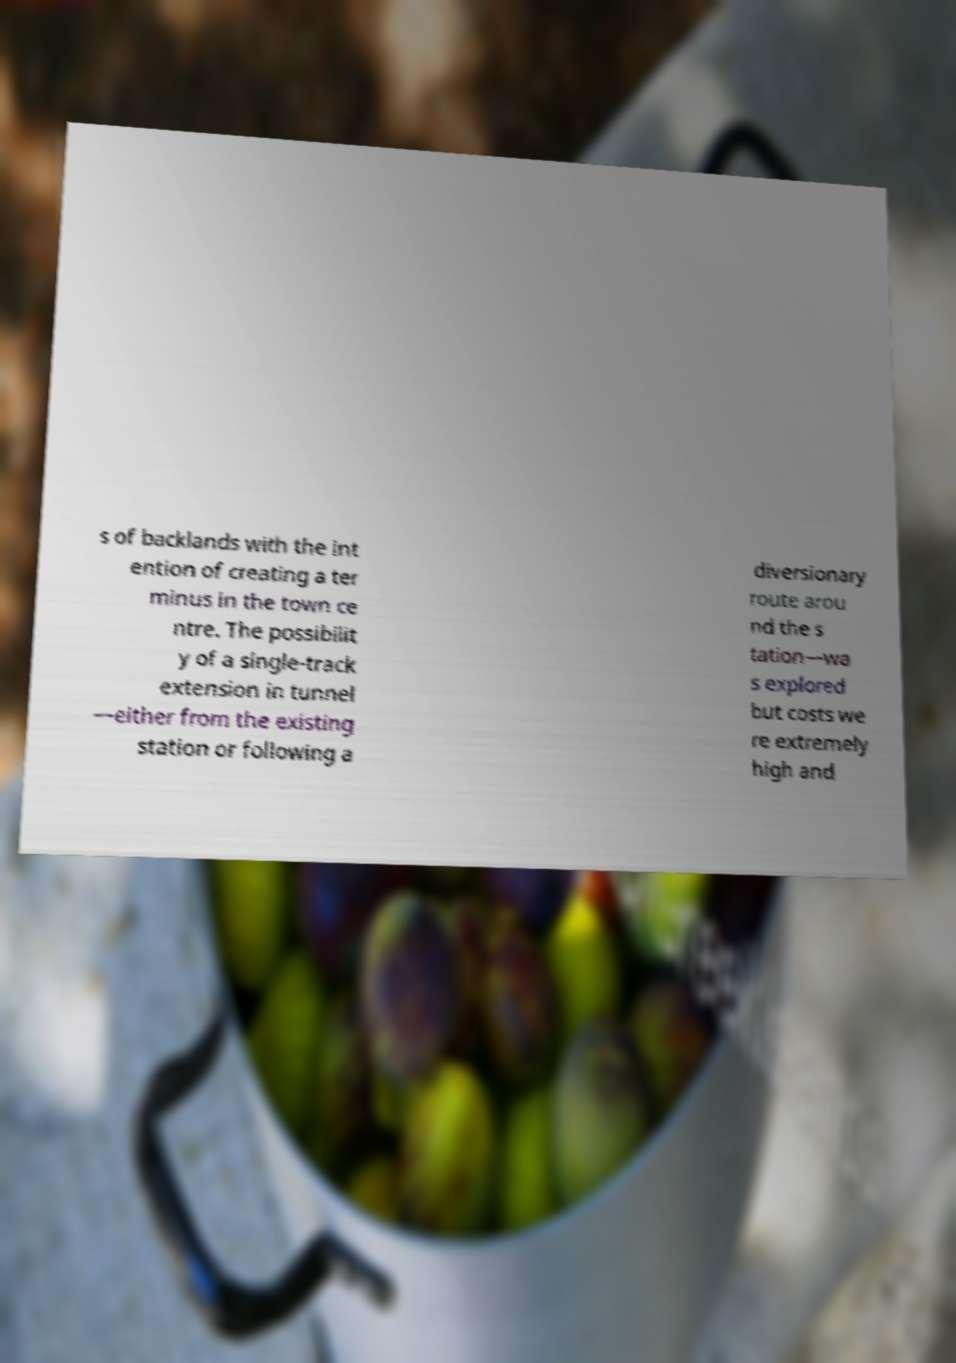Please identify and transcribe the text found in this image. s of backlands with the int ention of creating a ter minus in the town ce ntre. The possibilit y of a single-track extension in tunnel —either from the existing station or following a diversionary route arou nd the s tation—wa s explored but costs we re extremely high and 